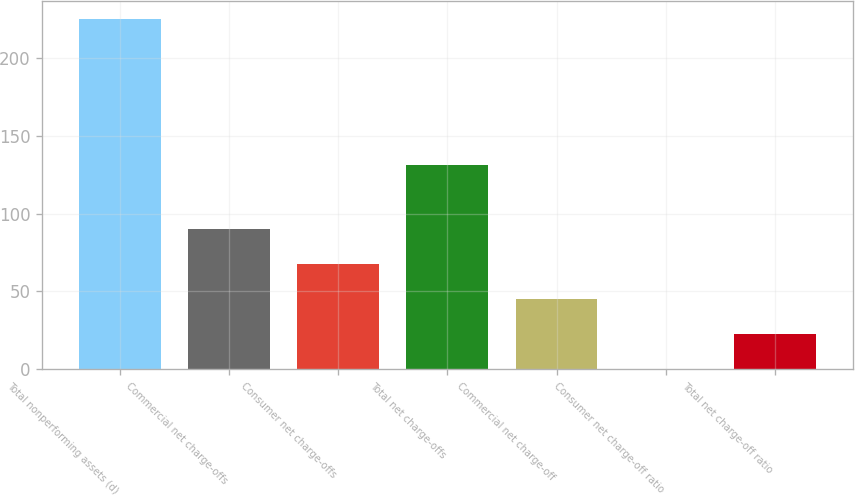Convert chart. <chart><loc_0><loc_0><loc_500><loc_500><bar_chart><fcel>Total nonperforming assets (d)<fcel>Commercial net charge-offs<fcel>Consumer net charge-offs<fcel>Total net charge-offs<fcel>Commercial net charge-off<fcel>Consumer net charge-off ratio<fcel>Total net charge-off ratio<nl><fcel>225<fcel>90.18<fcel>67.71<fcel>131<fcel>45.24<fcel>0.3<fcel>22.77<nl></chart> 